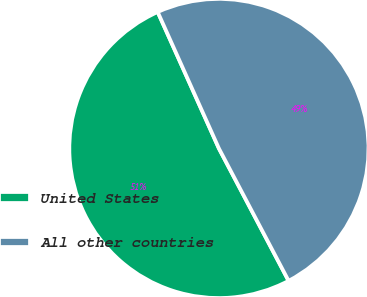<chart> <loc_0><loc_0><loc_500><loc_500><pie_chart><fcel>United States<fcel>All other countries<nl><fcel>51.0%<fcel>49.0%<nl></chart> 